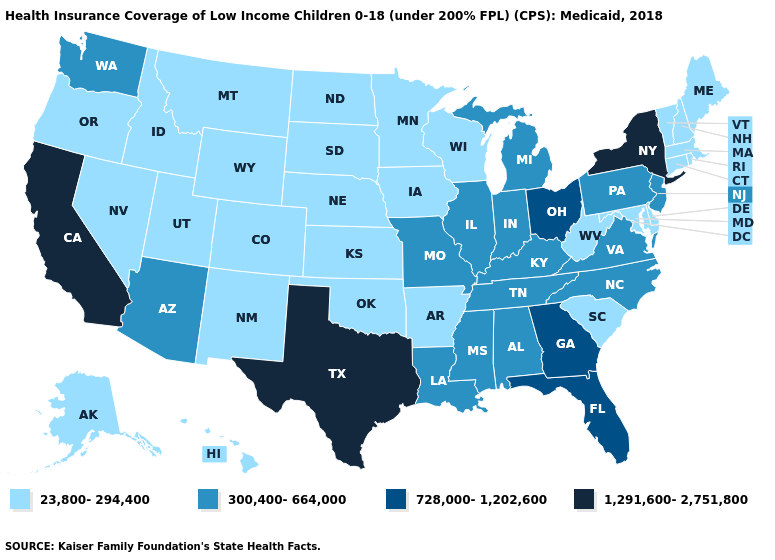Is the legend a continuous bar?
Give a very brief answer. No. What is the value of Wyoming?
Short answer required. 23,800-294,400. Does Texas have the highest value in the South?
Give a very brief answer. Yes. Does Arizona have the lowest value in the USA?
Answer briefly. No. What is the value of Montana?
Be succinct. 23,800-294,400. Does New Hampshire have a higher value than Alabama?
Concise answer only. No. Name the states that have a value in the range 300,400-664,000?
Be succinct. Alabama, Arizona, Illinois, Indiana, Kentucky, Louisiana, Michigan, Mississippi, Missouri, New Jersey, North Carolina, Pennsylvania, Tennessee, Virginia, Washington. Name the states that have a value in the range 728,000-1,202,600?
Answer briefly. Florida, Georgia, Ohio. Name the states that have a value in the range 1,291,600-2,751,800?
Answer briefly. California, New York, Texas. What is the value of Delaware?
Concise answer only. 23,800-294,400. Name the states that have a value in the range 23,800-294,400?
Be succinct. Alaska, Arkansas, Colorado, Connecticut, Delaware, Hawaii, Idaho, Iowa, Kansas, Maine, Maryland, Massachusetts, Minnesota, Montana, Nebraska, Nevada, New Hampshire, New Mexico, North Dakota, Oklahoma, Oregon, Rhode Island, South Carolina, South Dakota, Utah, Vermont, West Virginia, Wisconsin, Wyoming. Name the states that have a value in the range 300,400-664,000?
Answer briefly. Alabama, Arizona, Illinois, Indiana, Kentucky, Louisiana, Michigan, Mississippi, Missouri, New Jersey, North Carolina, Pennsylvania, Tennessee, Virginia, Washington. Does Virginia have a lower value than California?
Write a very short answer. Yes. What is the lowest value in the West?
Keep it brief. 23,800-294,400. 